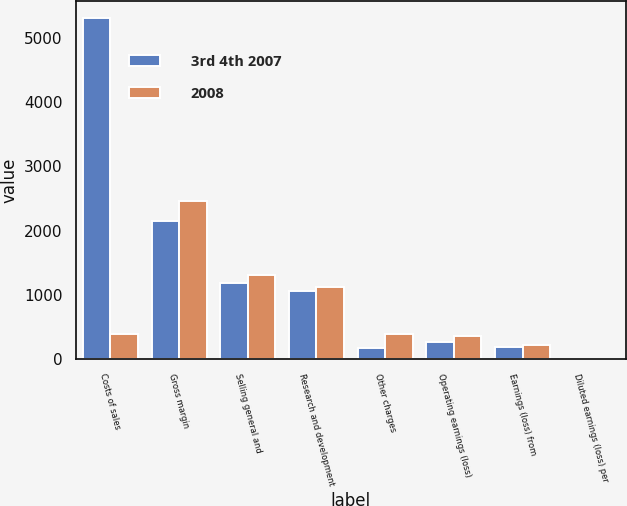Convert chart. <chart><loc_0><loc_0><loc_500><loc_500><stacked_bar_chart><ecel><fcel>Costs of sales<fcel>Gross margin<fcel>Selling general and<fcel>Research and development<fcel>Other charges<fcel>Operating earnings (loss)<fcel>Earnings (loss) from<fcel>Diluted earnings (loss) per<nl><fcel>3rd 4th 2007<fcel>5303<fcel>2145<fcel>1183<fcel>1054<fcel>177<fcel>269<fcel>194<fcel>0.09<nl><fcel>2008<fcel>390<fcel>2454<fcel>1313<fcel>1117<fcel>390<fcel>366<fcel>218<fcel>0.09<nl></chart> 